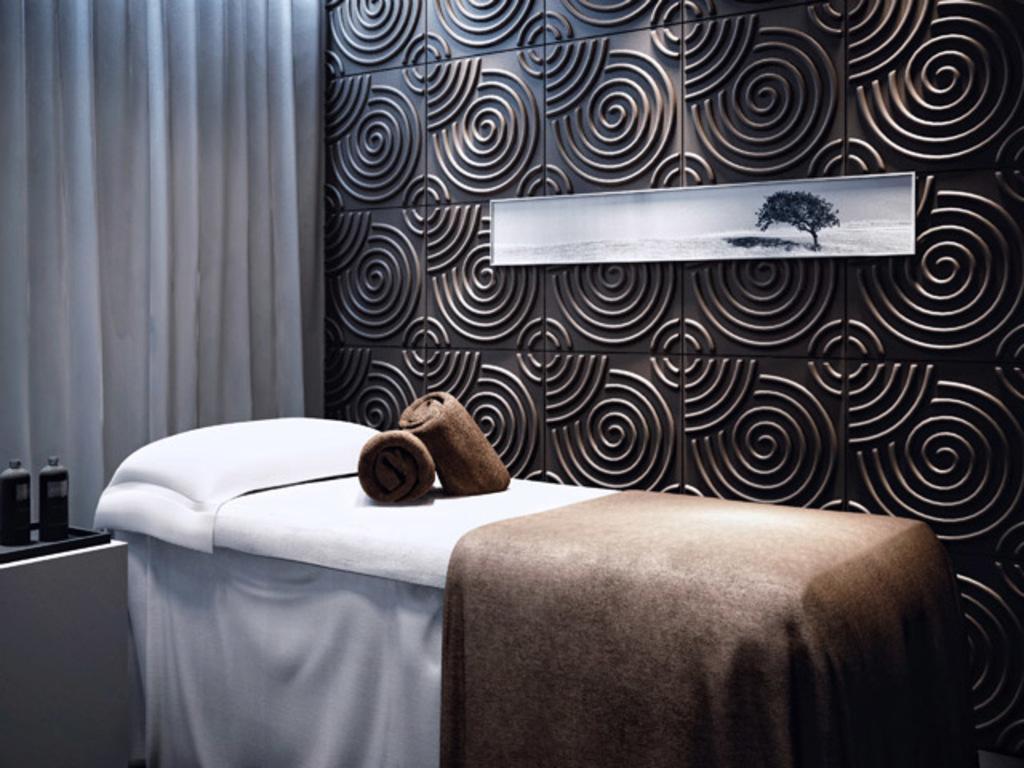How would you summarize this image in a sentence or two? In this image there is a bed. On top of it there is a blanket, pillow and folded towels. Beside the bed there are two bottles in the tray which is placed on the table. In the background of the image there are curtains. There is a photo frame on the wall. 